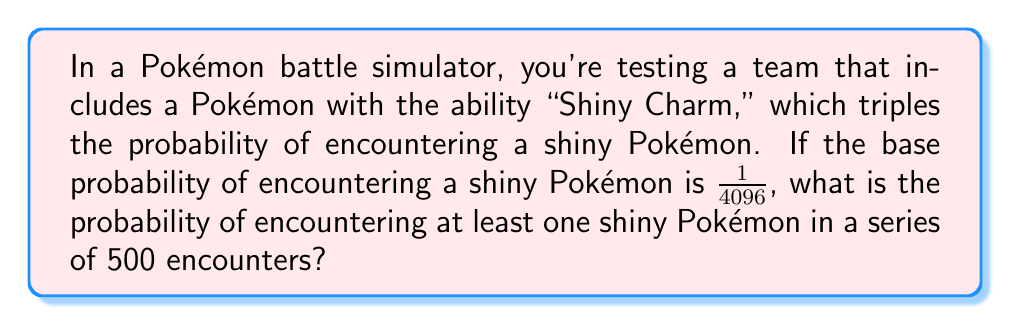Can you solve this math problem? Let's approach this step-by-step:

1) First, we need to calculate the probability of encountering a shiny Pokémon with the Shiny Charm ability:
   $P(\text{shiny with charm}) = 3 \times \frac{1}{4096} = \frac{3}{4096} = \frac{1}{1365.33}$

2) Now, let's calculate the probability of not encountering a shiny Pokémon in a single encounter:
   $P(\text{not shiny}) = 1 - \frac{1}{1365.33} = \frac{1364.33}{1365.33}$

3) For 500 encounters, the probability of not encountering any shiny Pokémon is:
   $P(\text{no shiny in 500}) = (\frac{1364.33}{1365.33})^{500}$

4) Therefore, the probability of encountering at least one shiny Pokémon in 500 encounters is:
   $P(\text{at least one shiny}) = 1 - (\frac{1364.33}{1365.33})^{500}$

5) Calculate this value:
   $1 - (\frac{1364.33}{1365.33})^{500} \approx 0.3069$

6) Convert to a percentage:
   $0.3069 \times 100\% \approx 30.69\%$
Answer: $30.69\%$ 